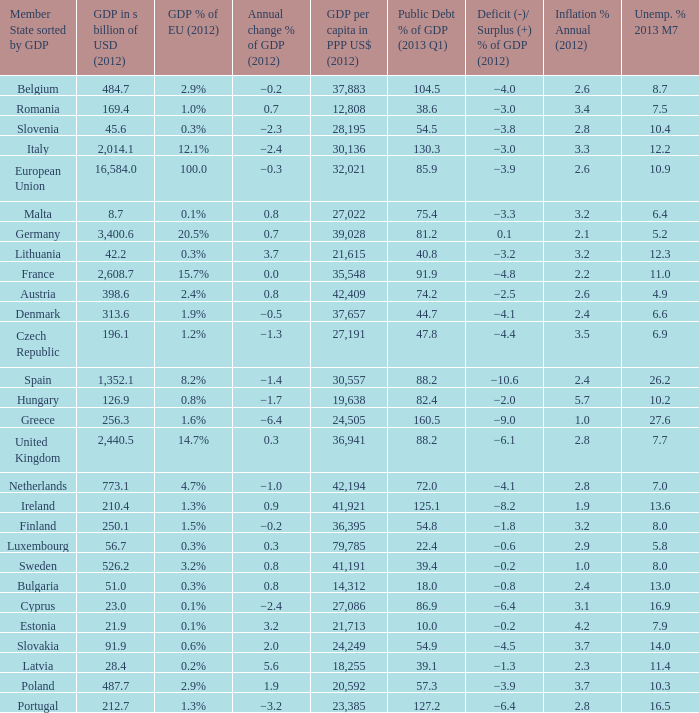What is the deficit/surplus % of the 2012 GDP of the country with a GDP in billions of USD in 2012 less than 1,352.1, a GDP per capita in PPP US dollars in 2012 greater than 21,615, public debt % of GDP in the 2013 Q1 less than 75.4, and an inflation % annual in 2012 of 2.9? −0.6. 